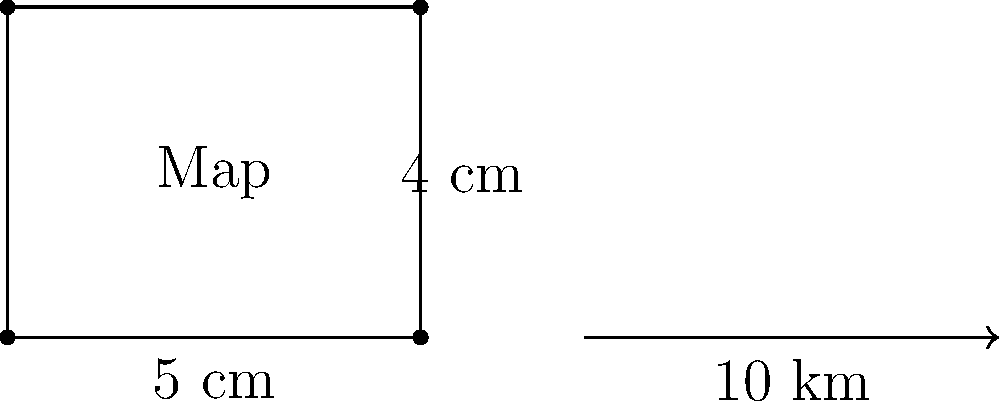You have discovered an old map of Caxias do Sul in the city archives. The map measures 5 cm by 4 cm. You know that the actual distance represented by the 5 cm side of the map is 10 km in reality. What is the scale of this map? To find the scale of the map, we need to follow these steps:

1. Identify the relationship between the map distance and the actual distance:
   5 cm on the map represents 10 km in reality

2. Convert the actual distance to the same unit as the map distance:
   10 km = 10,000 m = 1,000,000 cm

3. Set up the scale ratio:
   Map distance : Actual distance
   5 : 1,000,000

4. Simplify the ratio by dividing both sides by 5:
   1 : 200,000

5. Express the scale in the standard format:
   1:200,000

This means that 1 cm on the map represents 200,000 cm (or 2 km) in reality.
Answer: 1:200,000 